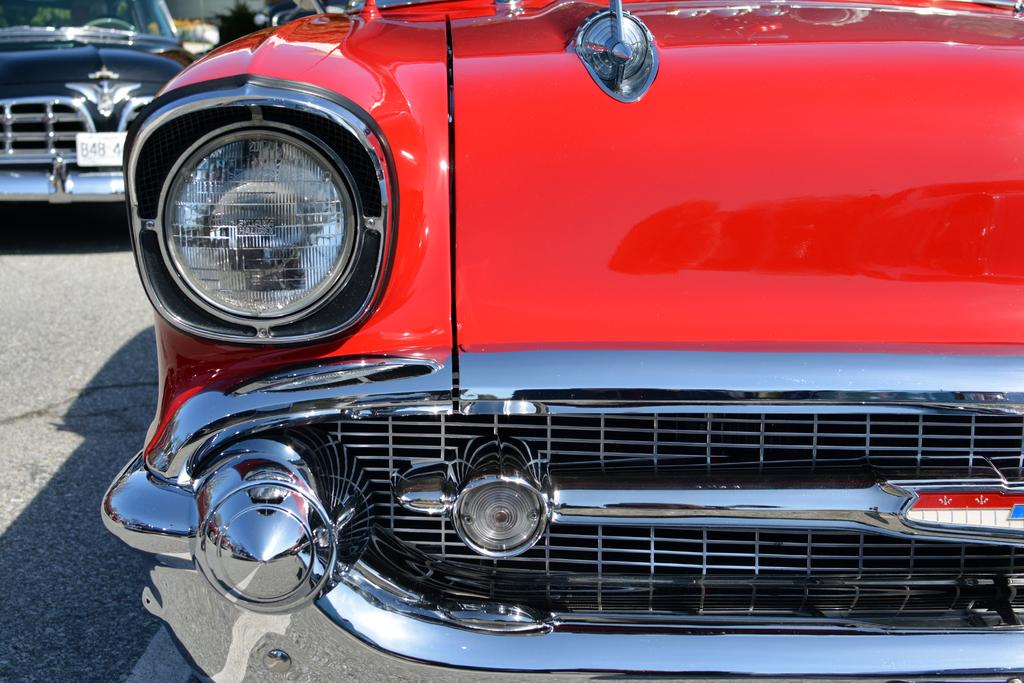What type of vehicles can be seen on the road in the image? There are cars on the road in the image. Where are the cars located in relation to the image? The cars are on the road in the front of the image. What can be seen in the background of the image? There are plants in the background of the image. What are the cars' hobbies in the image? Cars do not have hobbies, as they are inanimate objects. What is the cars' fear in the image? Cars do not have fears, as they are inanimate objects. 